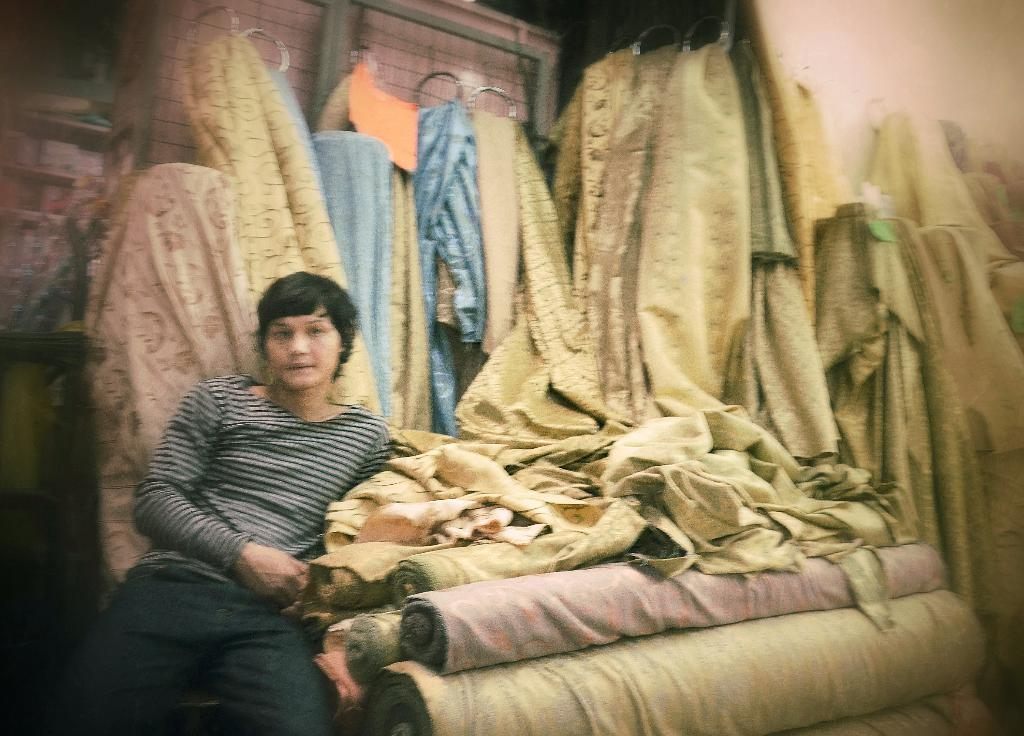What is the person in the image doing? The person is sitting in the image. What is located near the person in the image? The person is sitting beside clothes. How are the clothes arranged in the image? There are bundles of clothes and clothes hanging on a hanger in the image. What type of laborer can be seen working with the clothes in the image? There is no laborer present in the image, and the person sitting is not working with the clothes. What reason is given for the person sitting beside the clothes in the image? There is no specific reason provided for the person sitting beside the clothes in the image. 